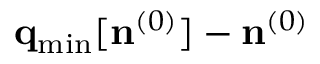<formula> <loc_0><loc_0><loc_500><loc_500>{ q } _ { \min } [ { n } ^ { ( 0 ) } ] - { n } ^ { ( 0 ) }</formula> 